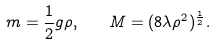<formula> <loc_0><loc_0><loc_500><loc_500>m = \frac { 1 } { 2 } g \rho , \quad M = ( 8 \lambda \rho ^ { 2 } ) ^ { \frac { 1 } { 2 } } .</formula> 